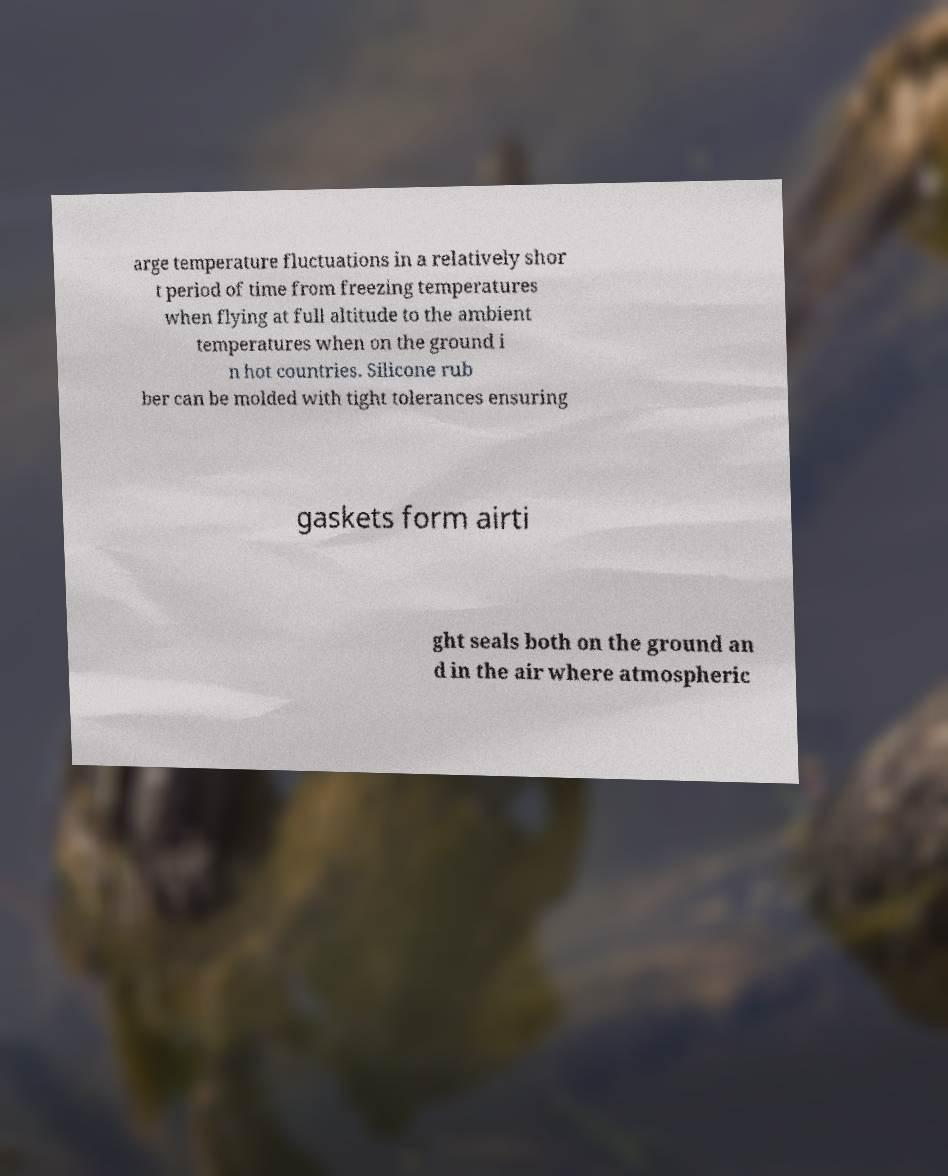For documentation purposes, I need the text within this image transcribed. Could you provide that? arge temperature fluctuations in a relatively shor t period of time from freezing temperatures when flying at full altitude to the ambient temperatures when on the ground i n hot countries. Silicone rub ber can be molded with tight tolerances ensuring gaskets form airti ght seals both on the ground an d in the air where atmospheric 